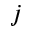<formula> <loc_0><loc_0><loc_500><loc_500>j</formula> 